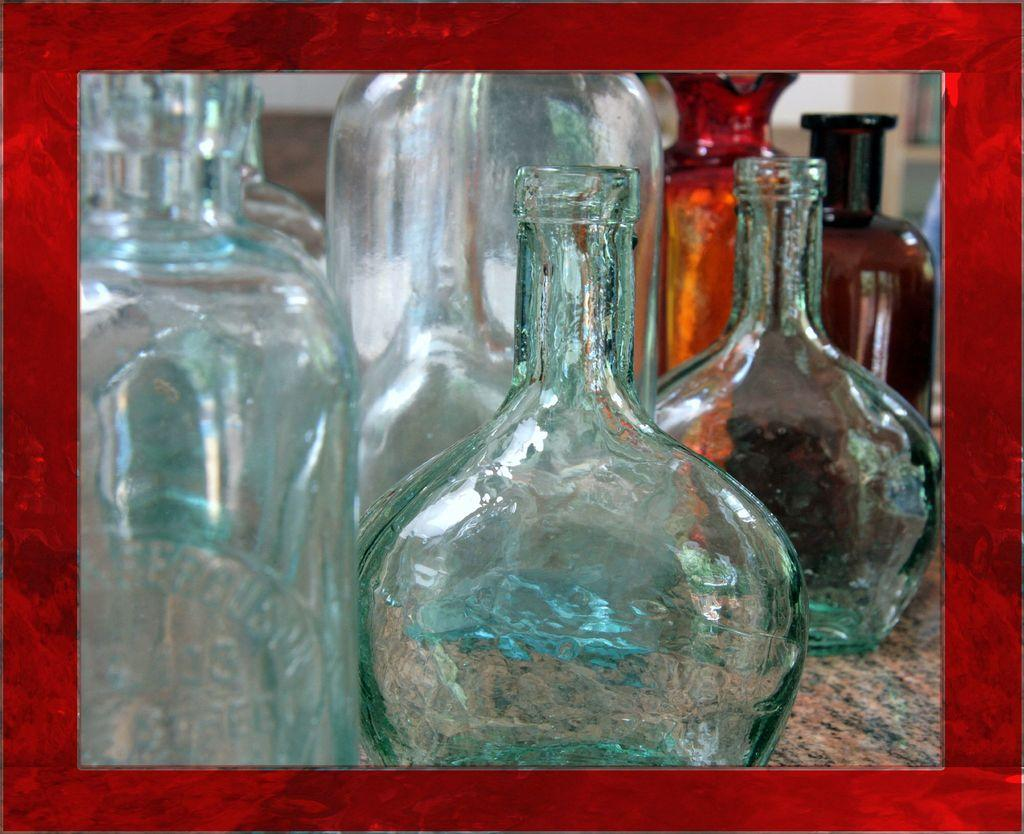What objects are present in the image? There are bottles in the image. Can you describe the bottles in the image? Unfortunately, the provided facts do not give any additional information about the bottles. What type of twist can be seen in the image? There is no twist present in the image; it only features bottles. 